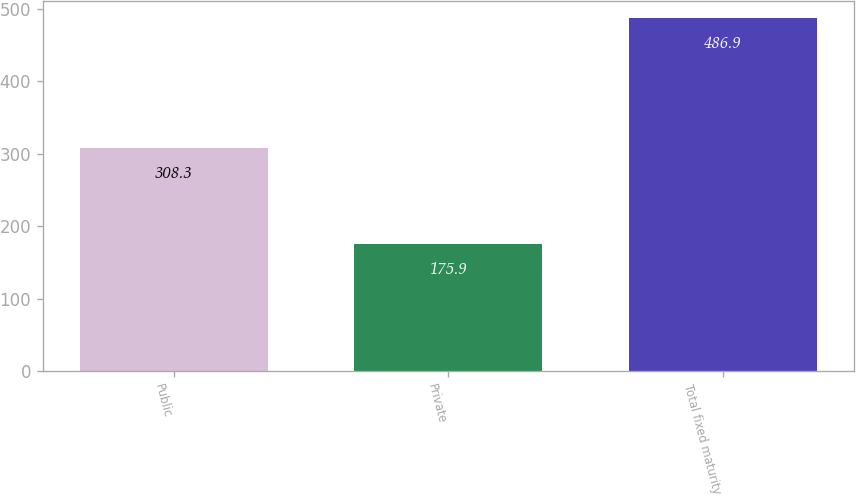Convert chart to OTSL. <chart><loc_0><loc_0><loc_500><loc_500><bar_chart><fcel>Public<fcel>Private<fcel>Total fixed maturity<nl><fcel>308.3<fcel>175.9<fcel>486.9<nl></chart> 